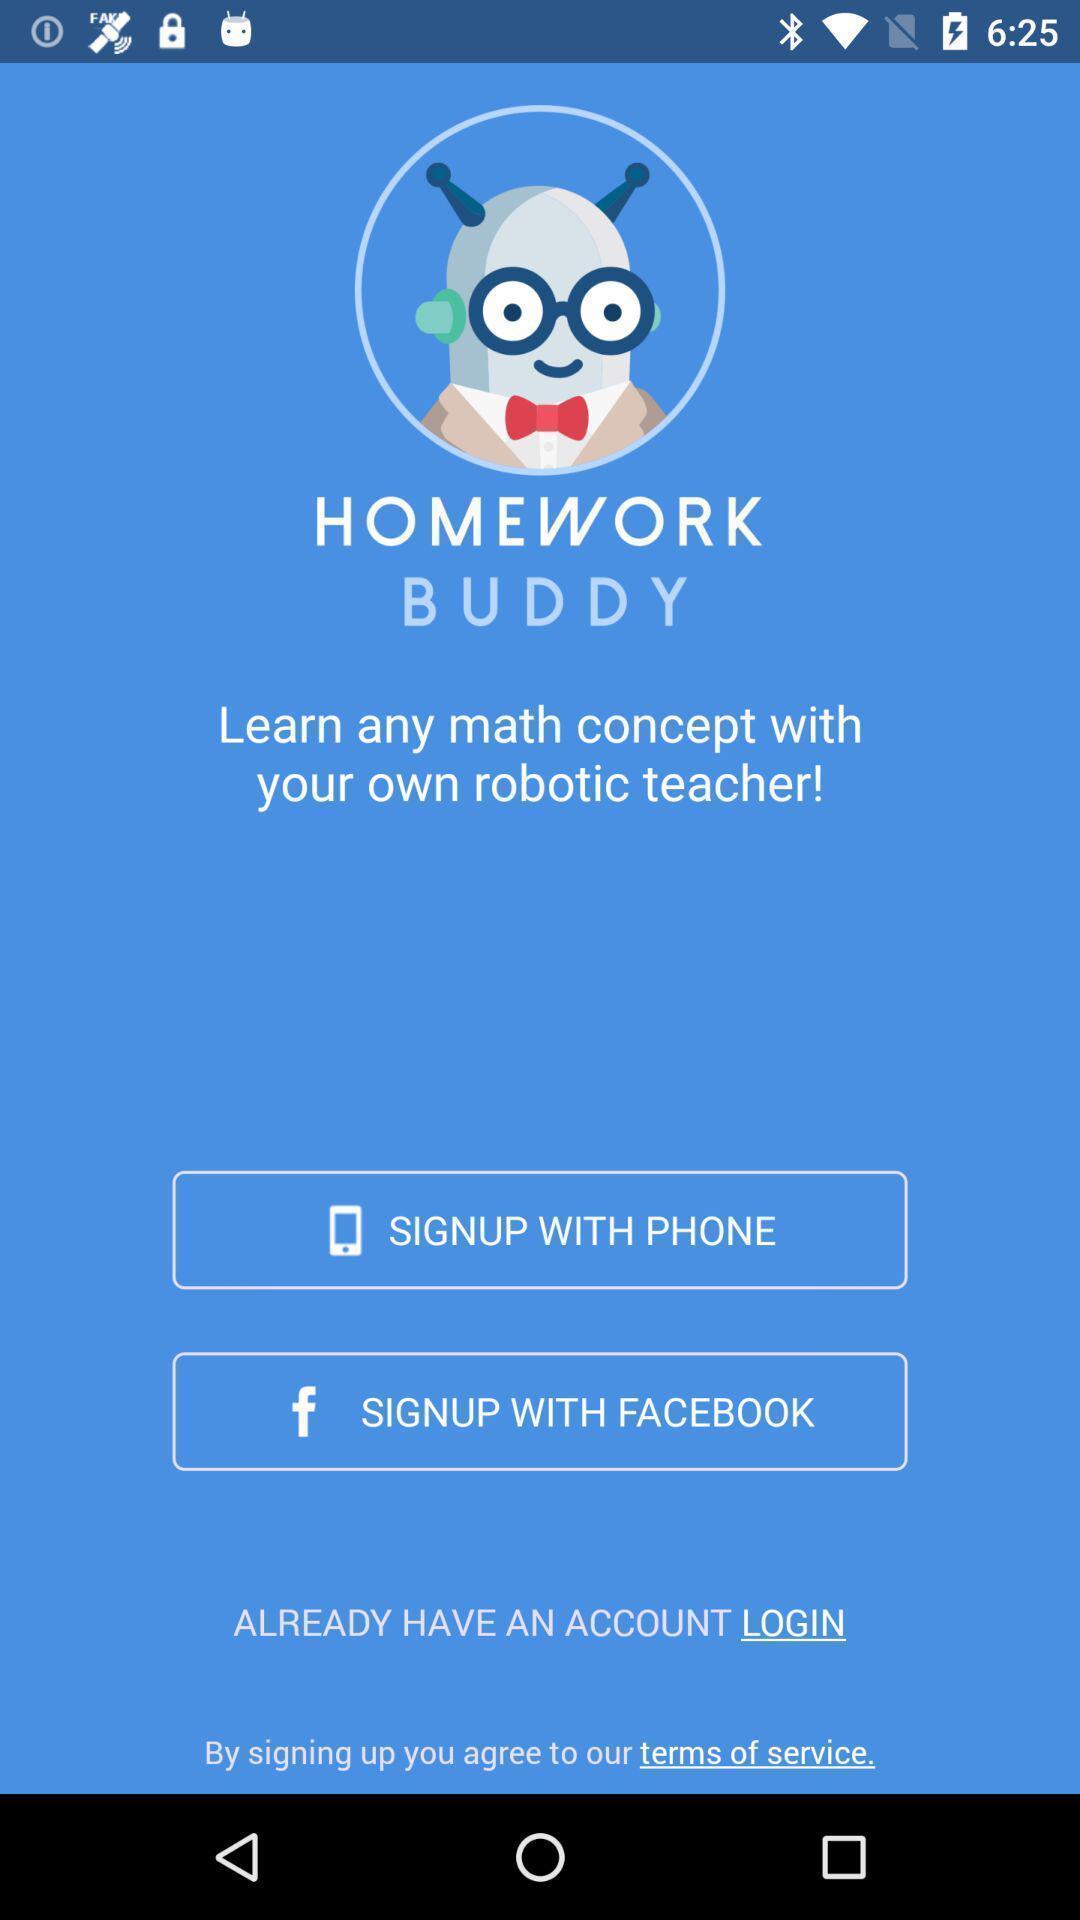Tell me about the visual elements in this screen capture. Sign in page for the math learning app. 